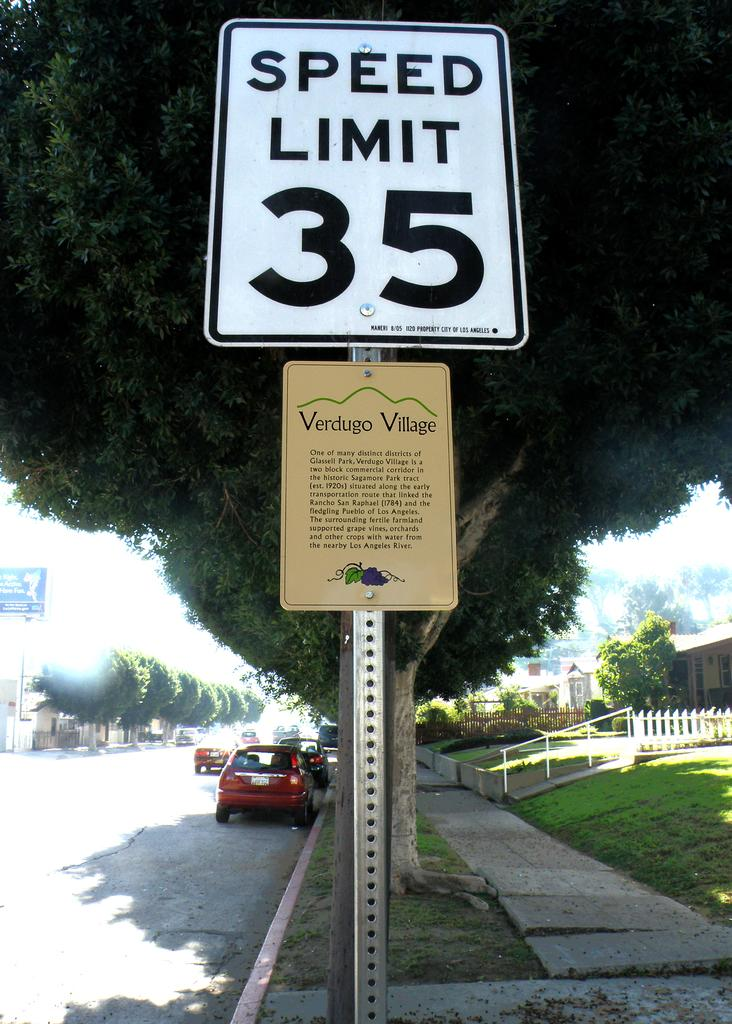<image>
Offer a succinct explanation of the picture presented. A speed limit sign that says Speed Limit 35 with Verdugo Village under it. 